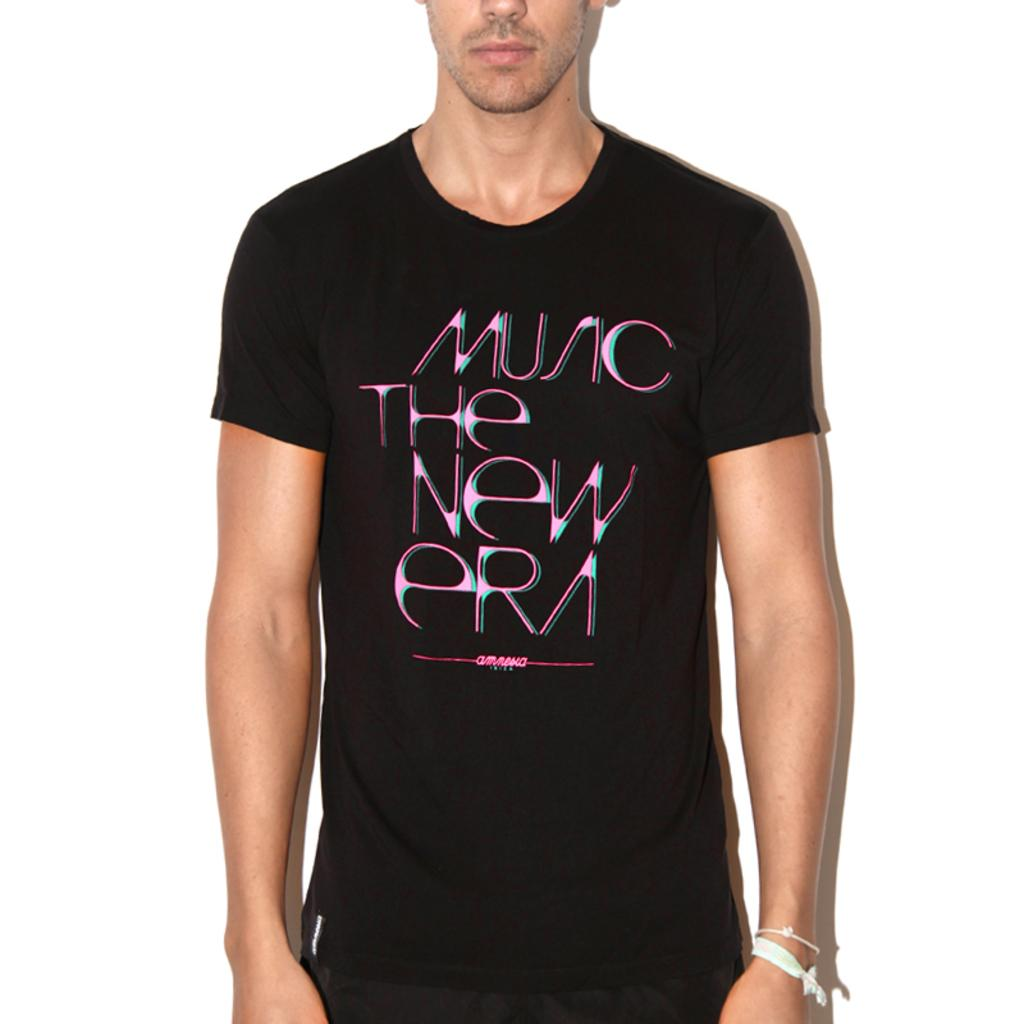Who or what is the main subject of the image? There is a person in the image. What is the person wearing? The person is wearing a black dress. What is the color of the background in the image? The background of the image is white. How many cats are visible in the image? There are no cats present in the image. What type of cloth is being used to cover the person in the image? The person is not covered by any cloth in the image; they are wearing a black dress. 